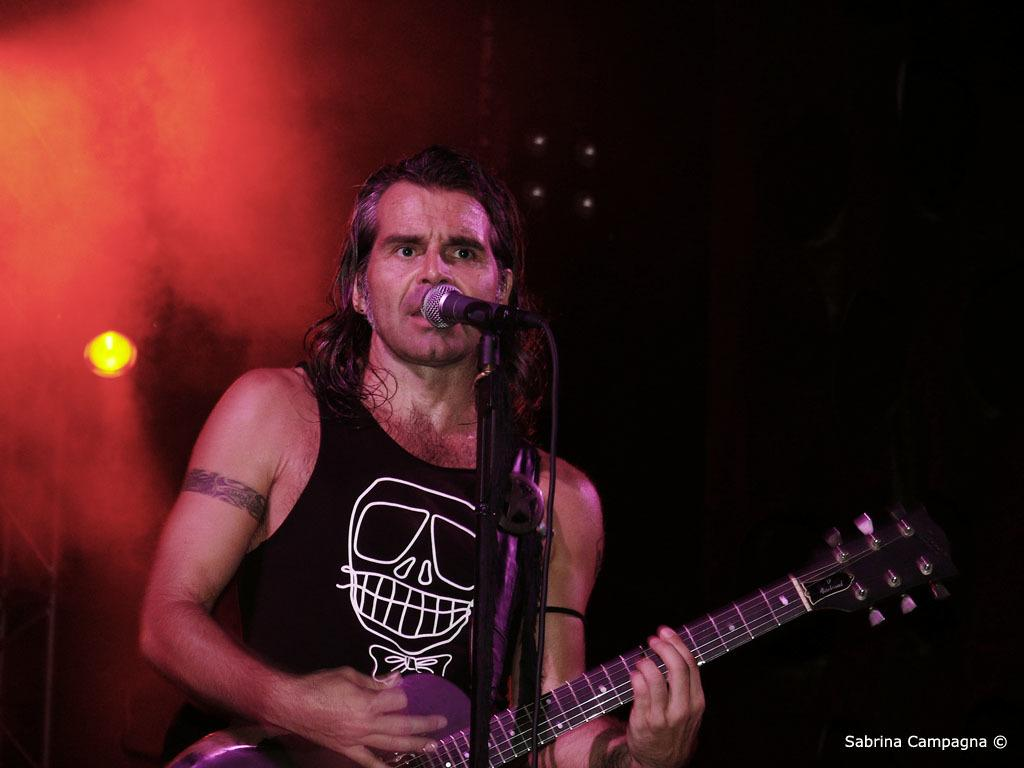What is the man in the image doing? The man is playing the guitar and singing on a microphone. What object is the man holding in the image? The man is holding a guitar. What can be seen in the background of the image? There is light in the background of the image. How would you describe the lighting conditions in the image? The image appears to be taken in a dark environment. What type of stitch is the man using to sew his shirt in the image? There is no indication in the image that the man is sewing his shirt or using any stitch. What kind of pet is sitting next to the man in the image? There is no pet present in the image. 